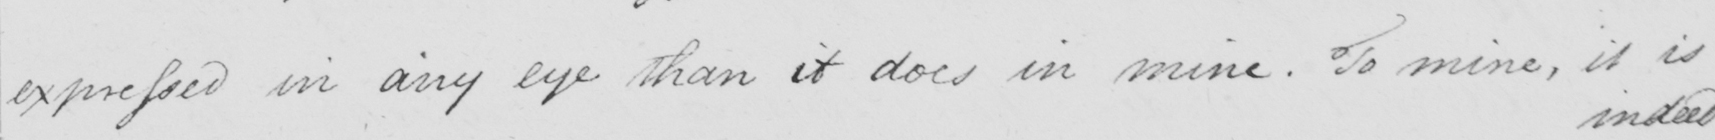What is written in this line of handwriting? expressed in any eye than it does in mine . To mine , it is 